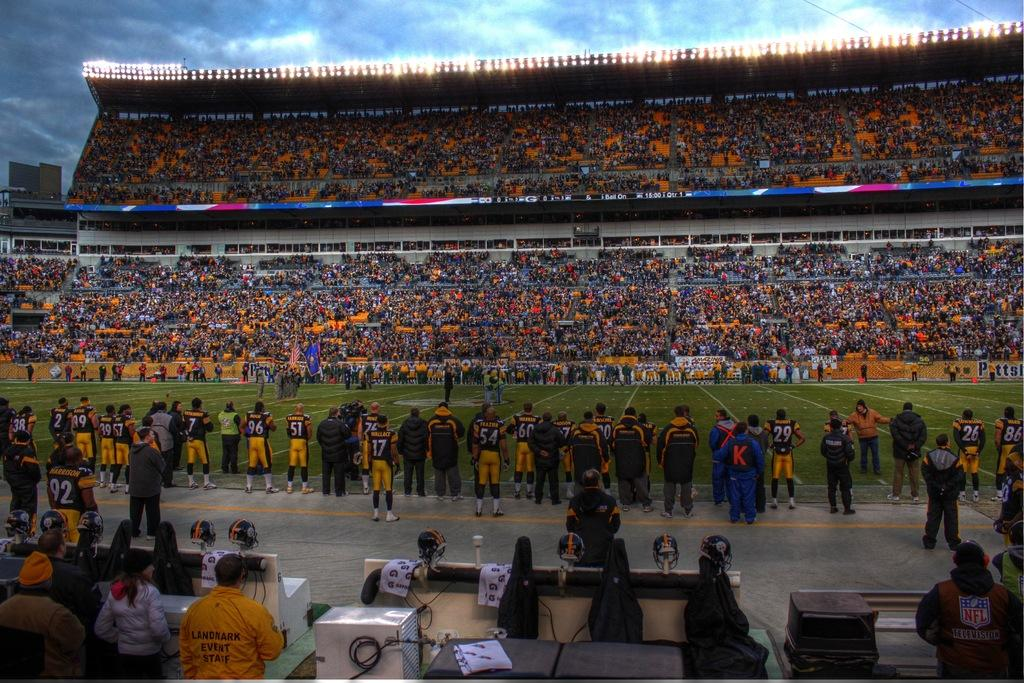What type of structure is shown in the image? There is a stadium in the image. Can you describe the people in the image? There are groups of people in the image. What protective gear can be seen in the image? There are helmets in the image. What can be used to illuminate the area in the image? There are lights in the image. What other objects are present in the image? There are other objects in the image. What can be seen in the background of the image? The sky is visible in the background of the image. What type of ink is being used by the people in the image? There is no ink present in the image; it is a stadium with groups of people, helmets, lights, and other objects. What kind of hammer can be seen being used by the people in the image? There is no hammer present in the image; it is a stadium with groups of people, helmets, lights, and other objects. 